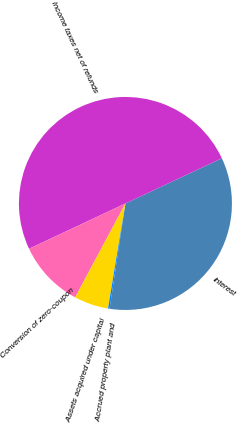<chart> <loc_0><loc_0><loc_500><loc_500><pie_chart><fcel>Interest<fcel>Income taxes net of refunds<fcel>Conversion of zero-coupon<fcel>Assets acquired under capital<fcel>Accrued property plant and<nl><fcel>34.36%<fcel>50.01%<fcel>10.19%<fcel>5.21%<fcel>0.23%<nl></chart> 